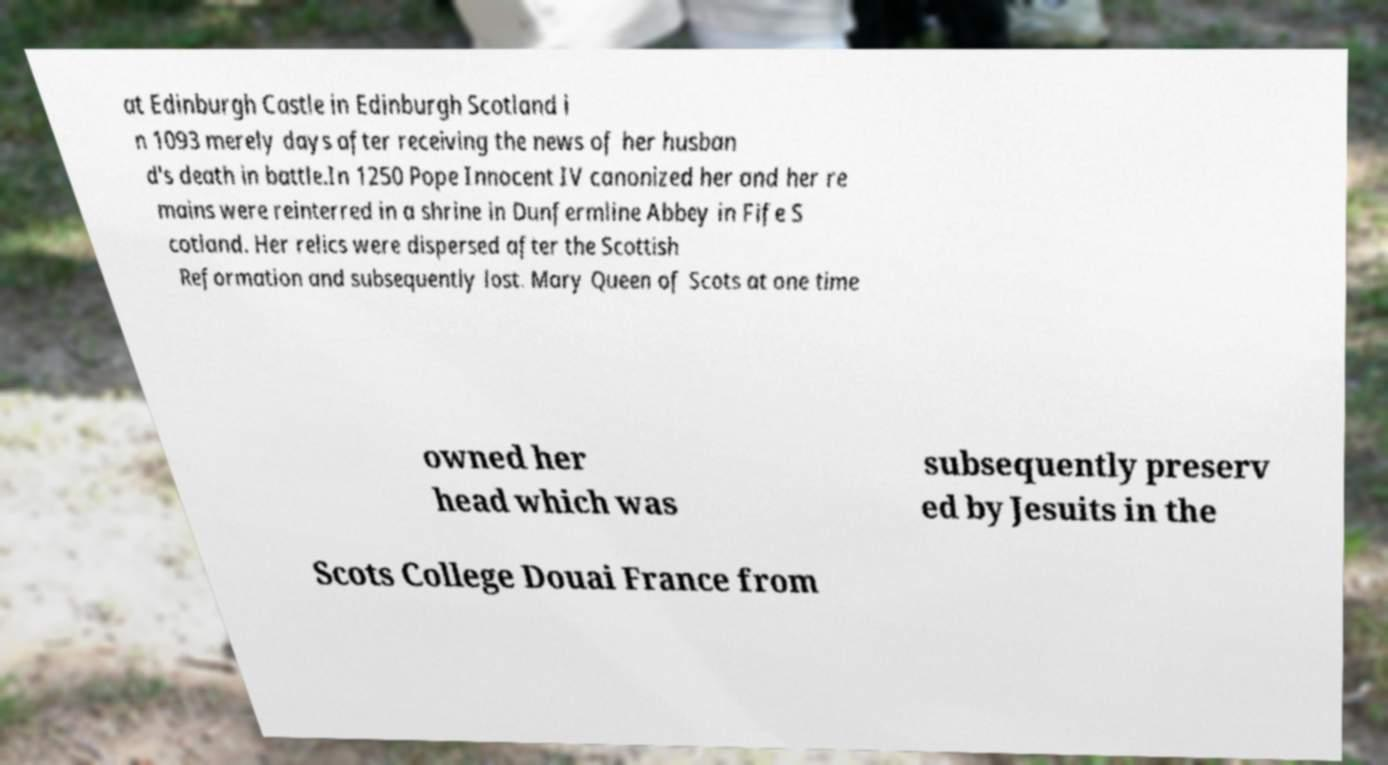Can you accurately transcribe the text from the provided image for me? at Edinburgh Castle in Edinburgh Scotland i n 1093 merely days after receiving the news of her husban d's death in battle.In 1250 Pope Innocent IV canonized her and her re mains were reinterred in a shrine in Dunfermline Abbey in Fife S cotland. Her relics were dispersed after the Scottish Reformation and subsequently lost. Mary Queen of Scots at one time owned her head which was subsequently preserv ed by Jesuits in the Scots College Douai France from 